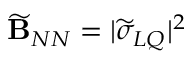Convert formula to latex. <formula><loc_0><loc_0><loc_500><loc_500>\widetilde { B } _ { N N } = | \widetilde { \sigma } _ { L Q } | ^ { 2 }</formula> 